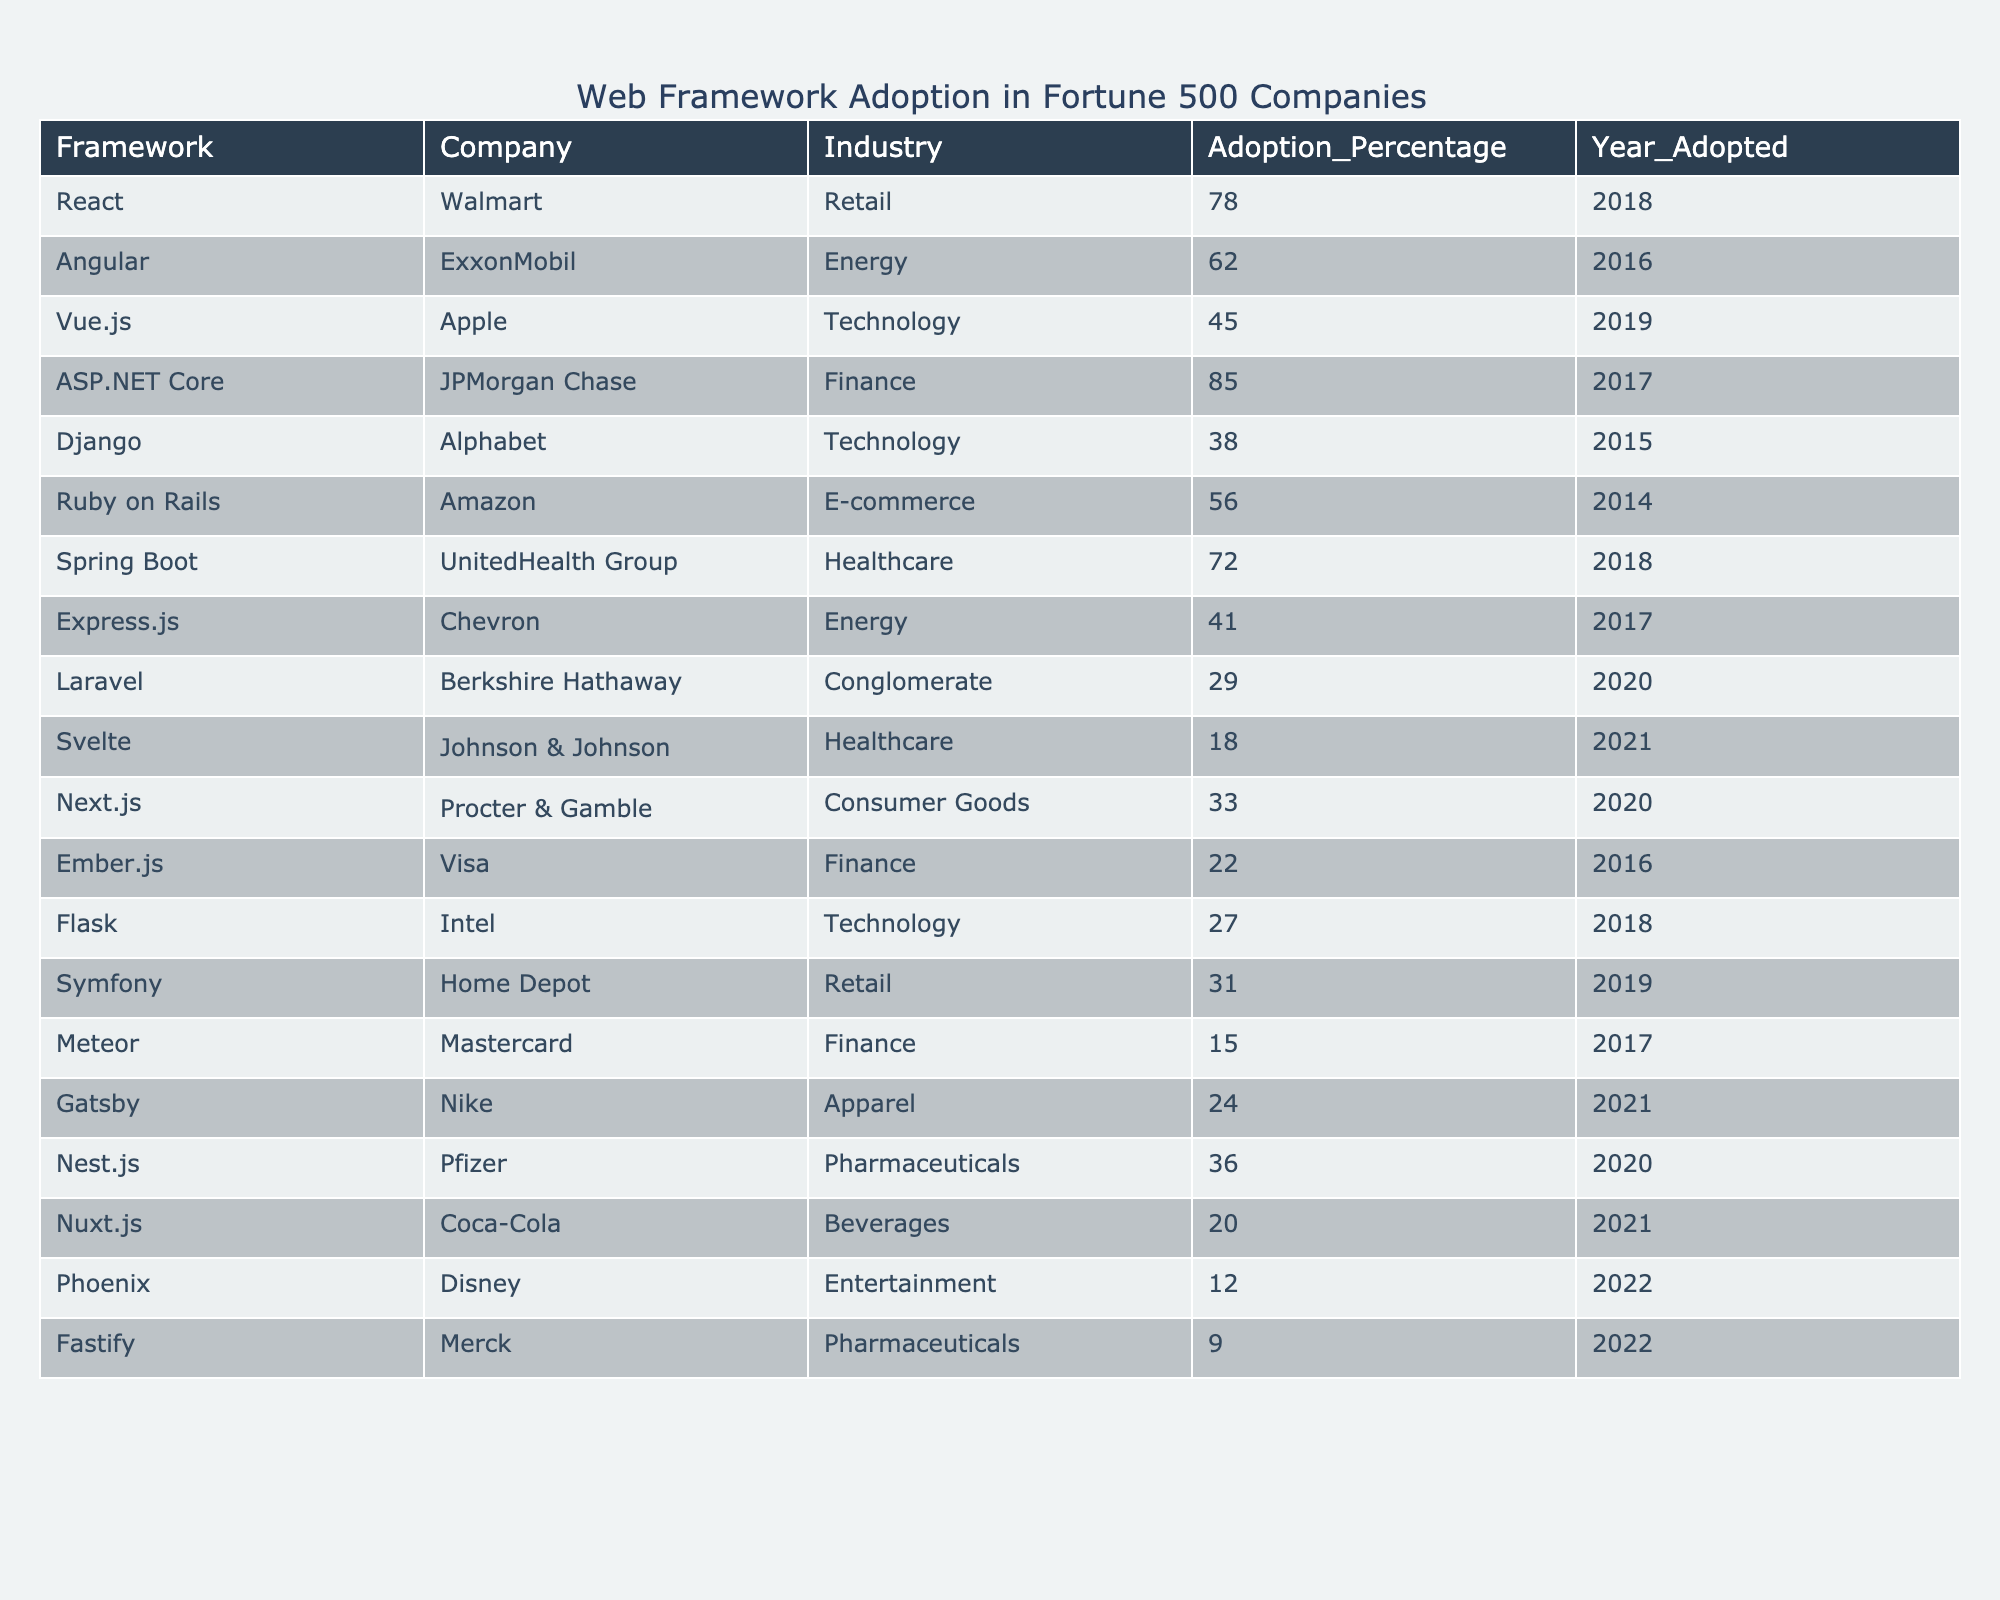What is the highest adoption percentage for a framework among Fortune 500 companies? The table shows that ASP.NET Core has the highest adoption percentage at 85%.
Answer: 85 Which company adopted Vue.js and in what year? According to the table, Apple adopted Vue.js in 2019.
Answer: Apple, 2019 How many frameworks have an adoption percentage above 70%? The frameworks with adoption percentages above 70% are ASP.NET Core (85%), React (78%), and Spring Boot (72). This makes a total of 3 frameworks.
Answer: 3 Which industry has the lowest adoption percentage for any framework? The lowest adoption percentage is for Fastify in the Pharmaceuticals industry, at 9%.
Answer: Pharmaceuticals, 9% Is there any framework that has been adopted by more than one company in the table? No, each framework listed in the table is associated with a unique company, indicating that none of them have been adopted by more than one company.
Answer: No What is the average adoption percentage for frameworks in the Technology industry? The adoption percentages for the Technology industry are 45% (Vue.js), 38% (Django), and 27% (Flask). To find the average, we compute (45 + 38 + 27) / 3 = 36.67.
Answer: 36.67 Which framework has the latest adoption year? The table shows that the latest adoption year is 2022 with the frameworks Phoenix and Fastify adopting at that time.
Answer: Phoenix and Fastify, 2022 Compare the adoption percentages of express.js and Django. Which one has a higher percentage? Express.js has an adoption percentage of 41%, while Django has 38%. Therefore, Express.js has a higher percentage.
Answer: Express.js What is the difference in adoption percentages between the highest (ASP.NET Core) and the lowest (Fastify)? The adoption percentage for ASP.NET Core is 85% and for Fastify, it is 9%. The difference is calculated as 85 - 9 = 76.
Answer: 76 How many frameworks were adopted after 2019? The frameworks adopted after 2019 are Laravel (2020), Next.js (2020), Nest.js (2020), Nuxt.js (2021), Svelte (2021), Gatsby (2021), Phoenix (2022), and Fastify (2022), totaling 8 frameworks.
Answer: 8 